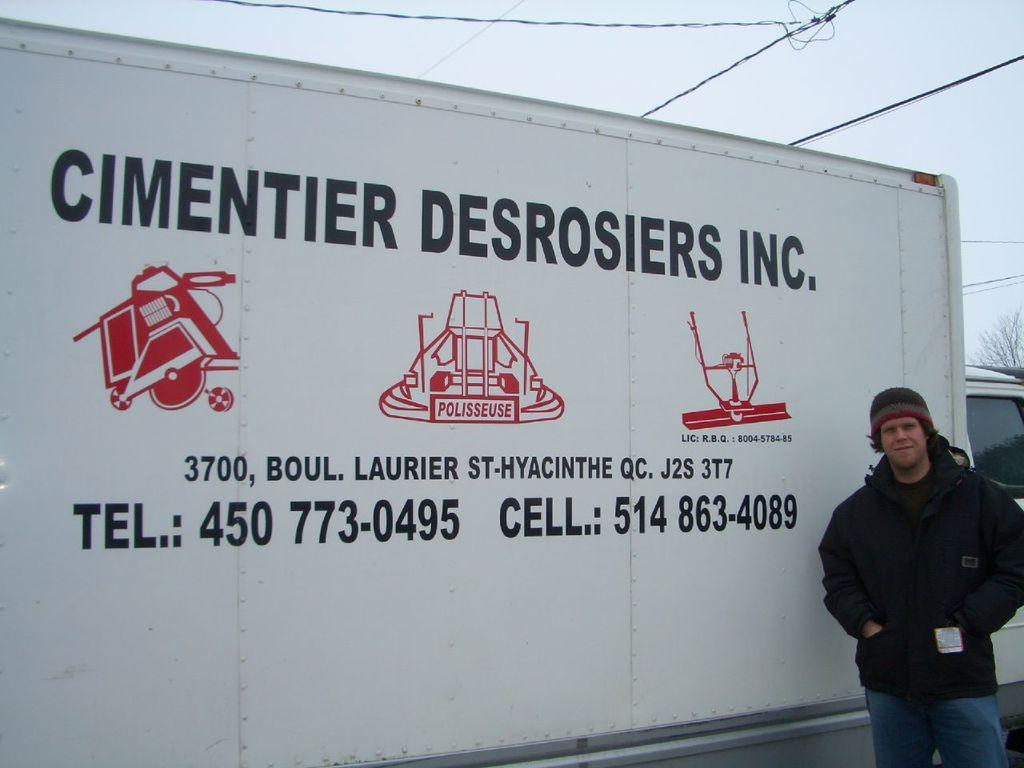What is the main subject in the middle of the image? There is text and images on a board in the middle of the image. Who is present on the right side of the image? There is a man wearing a coat on the right side of the image. What can be seen at the top of the image? The sky is visible at the top of the image. How many limits can be seen in the image? There are no limits visible in the image. What type of head is depicted on the board in the image? There is no head depicted on the board in the image; it contains text and images. 